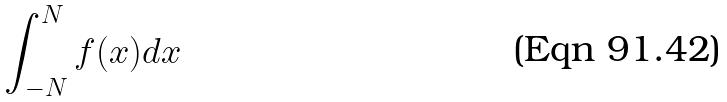Convert formula to latex. <formula><loc_0><loc_0><loc_500><loc_500>\int _ { - N } ^ { N } f ( x ) d x</formula> 